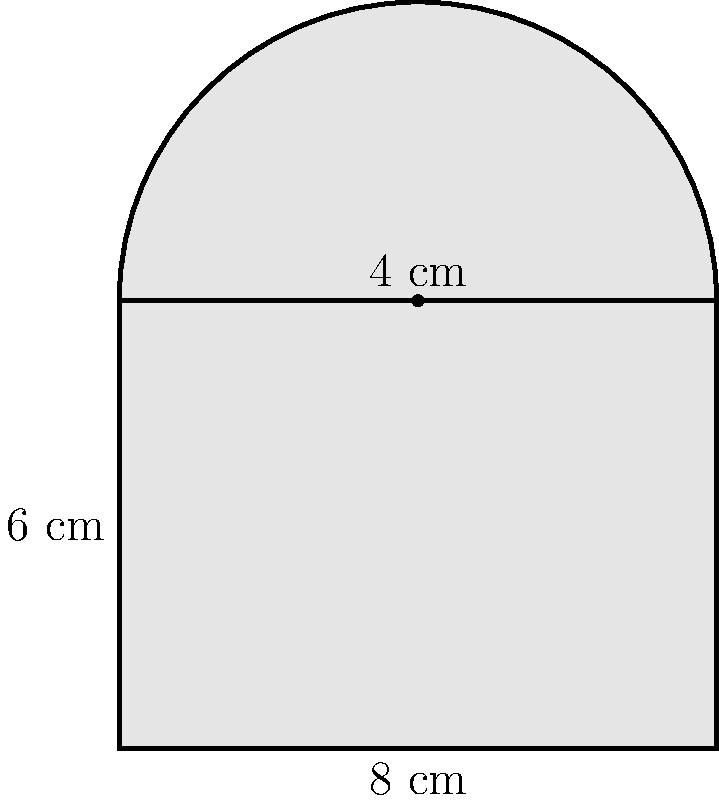Calculate the total area of the shape shown above, which consists of a rectangle with a semicircle on top. All measurements are in centimeters. To find the total area, we'll calculate the areas of the rectangle and semicircle separately, then add them together.

1. Area of the rectangle:
   $A_r = l \times w = 8 \text{ cm} \times 6 \text{ cm} = 48 \text{ cm}^2$

2. Area of the semicircle:
   Radius = 4 cm
   $A_s = \frac{1}{2} \times \pi r^2 = \frac{1}{2} \times \pi \times (4 \text{ cm})^2 = 8\pi \text{ cm}^2$

3. Total area:
   $A_{\text{total}} = A_r + A_s = 48 \text{ cm}^2 + 8\pi \text{ cm}^2 = (48 + 8\pi) \text{ cm}^2$
Answer: $(48 + 8\pi) \text{ cm}^2$ 